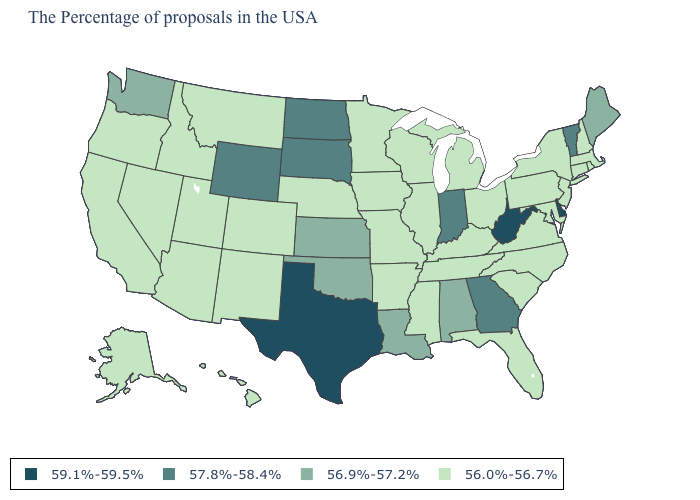What is the value of Utah?
Short answer required. 56.0%-56.7%. Name the states that have a value in the range 56.9%-57.2%?
Answer briefly. Maine, Alabama, Louisiana, Kansas, Oklahoma, Washington. Which states hav the highest value in the MidWest?
Keep it brief. Indiana, South Dakota, North Dakota. What is the value of Nevada?
Keep it brief. 56.0%-56.7%. Does Alabama have a lower value than Indiana?
Give a very brief answer. Yes. Does Pennsylvania have a higher value than Virginia?
Write a very short answer. No. Does the first symbol in the legend represent the smallest category?
Give a very brief answer. No. Name the states that have a value in the range 56.9%-57.2%?
Concise answer only. Maine, Alabama, Louisiana, Kansas, Oklahoma, Washington. Among the states that border Arkansas , which have the highest value?
Write a very short answer. Texas. What is the lowest value in the USA?
Be succinct. 56.0%-56.7%. Does the first symbol in the legend represent the smallest category?
Short answer required. No. Among the states that border Kentucky , does Tennessee have the highest value?
Short answer required. No. Name the states that have a value in the range 57.8%-58.4%?
Give a very brief answer. Vermont, Georgia, Indiana, South Dakota, North Dakota, Wyoming. Does Tennessee have a lower value than Indiana?
Write a very short answer. Yes. Among the states that border Illinois , which have the lowest value?
Write a very short answer. Kentucky, Wisconsin, Missouri, Iowa. 